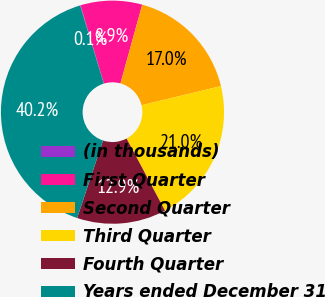Convert chart to OTSL. <chart><loc_0><loc_0><loc_500><loc_500><pie_chart><fcel>(in thousands)<fcel>First Quarter<fcel>Second Quarter<fcel>Third Quarter<fcel>Fourth Quarter<fcel>Years ended December 31<nl><fcel>0.06%<fcel>8.92%<fcel>16.95%<fcel>20.96%<fcel>12.93%<fcel>40.18%<nl></chart> 